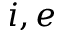<formula> <loc_0><loc_0><loc_500><loc_500>i , e</formula> 